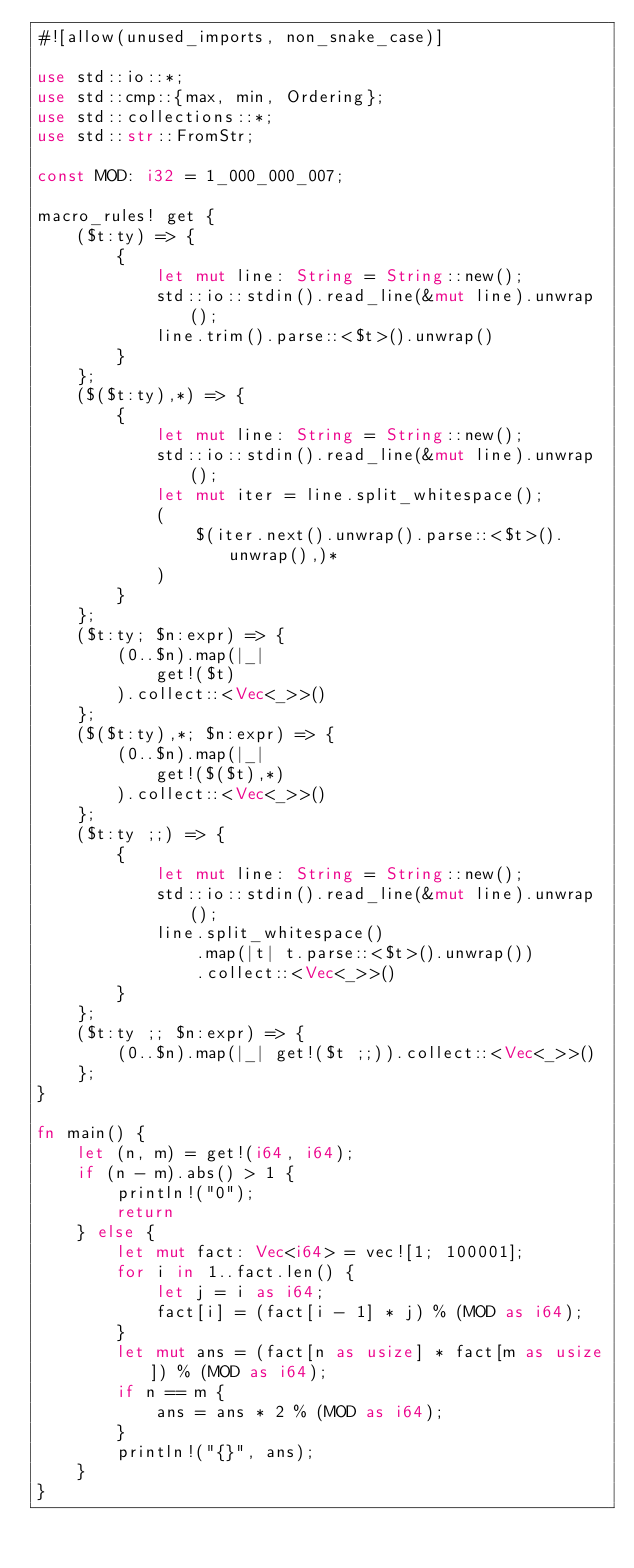<code> <loc_0><loc_0><loc_500><loc_500><_Rust_>#![allow(unused_imports, non_snake_case)]

use std::io::*;
use std::cmp::{max, min, Ordering};
use std::collections::*;
use std::str::FromStr;

const MOD: i32 = 1_000_000_007;

macro_rules! get {
    ($t:ty) => {
        {
            let mut line: String = String::new();
            std::io::stdin().read_line(&mut line).unwrap();
            line.trim().parse::<$t>().unwrap()
        }
    };
    ($($t:ty),*) => {
        {
            let mut line: String = String::new();
            std::io::stdin().read_line(&mut line).unwrap();
            let mut iter = line.split_whitespace();
            (
                $(iter.next().unwrap().parse::<$t>().unwrap(),)*
            )
        }
    };
    ($t:ty; $n:expr) => {
        (0..$n).map(|_|
            get!($t)
        ).collect::<Vec<_>>()
    };
    ($($t:ty),*; $n:expr) => {
        (0..$n).map(|_|
            get!($($t),*)
        ).collect::<Vec<_>>()
    };
    ($t:ty ;;) => {
        {
            let mut line: String = String::new();
            std::io::stdin().read_line(&mut line).unwrap();
            line.split_whitespace()
                .map(|t| t.parse::<$t>().unwrap())
                .collect::<Vec<_>>()
        }
    };
    ($t:ty ;; $n:expr) => {
        (0..$n).map(|_| get!($t ;;)).collect::<Vec<_>>()
    };
}

fn main() {
    let (n, m) = get!(i64, i64);
    if (n - m).abs() > 1 {
        println!("0");
        return
    } else {
        let mut fact: Vec<i64> = vec![1; 100001];
        for i in 1..fact.len() {
            let j = i as i64;
            fact[i] = (fact[i - 1] * j) % (MOD as i64);
        }
        let mut ans = (fact[n as usize] * fact[m as usize]) % (MOD as i64);
        if n == m {
            ans = ans * 2 % (MOD as i64);
        }
        println!("{}", ans);
    }
}</code> 